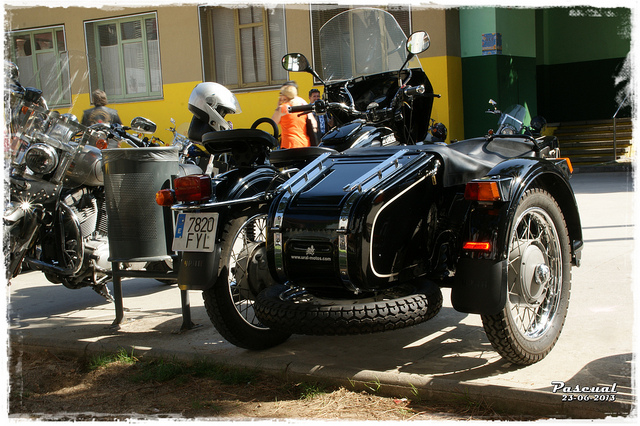Please identify all text content in this image. 7820 FYL Pascual 2013 06 